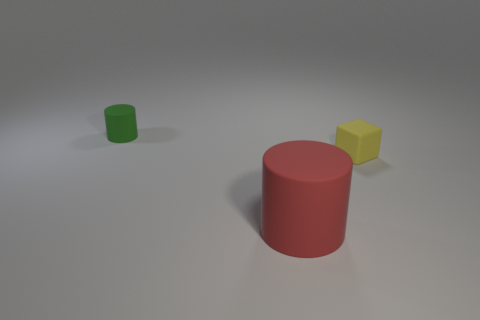There is a green rubber object; is its shape the same as the rubber object in front of the tiny yellow cube?
Offer a terse response. Yes. What number of cylinders are behind the big red rubber thing and in front of the green thing?
Keep it short and to the point. 0. There is a yellow rubber object that is in front of the cylinder behind the tiny yellow rubber cube; what is its size?
Your answer should be very brief. Small. Are any tiny red blocks visible?
Your response must be concise. No. There is a object that is left of the yellow block and behind the large red object; what is its material?
Make the answer very short. Rubber. Are there more tiny objects in front of the green object than tiny yellow matte cubes that are in front of the yellow block?
Keep it short and to the point. Yes. Are there any green cylinders of the same size as the yellow matte thing?
Your answer should be compact. Yes. How big is the object behind the small object that is to the right of the matte object behind the small yellow rubber cube?
Keep it short and to the point. Small. The small rubber cylinder is what color?
Provide a short and direct response. Green. Are there more red cylinders that are in front of the big red cylinder than tiny cyan metallic cylinders?
Provide a succinct answer. No. 